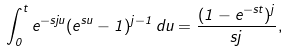Convert formula to latex. <formula><loc_0><loc_0><loc_500><loc_500>\int _ { 0 } ^ { t } e ^ { - s j u } ( e ^ { s u } - 1 ) ^ { j - 1 } \, d u = \frac { ( 1 - e ^ { - s t } ) ^ { j } } { s j } ,</formula> 